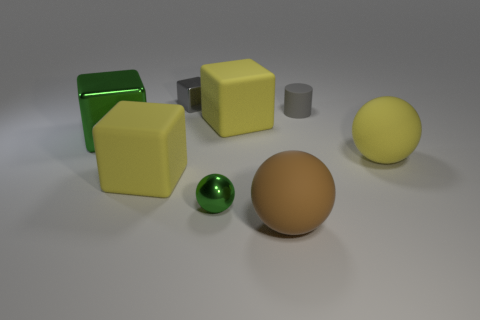What is the mood created by the composition and lighting of this scene? The composition and soft, diffused lighting of the scene evoke a calm and tranquil mood. The simplicity of the shapes and the harmonious color palette, along with the gentle shadows, contribute to a serene and orderly atmosphere, making it appear as if it's a setting designed for quiet contemplation or study. 